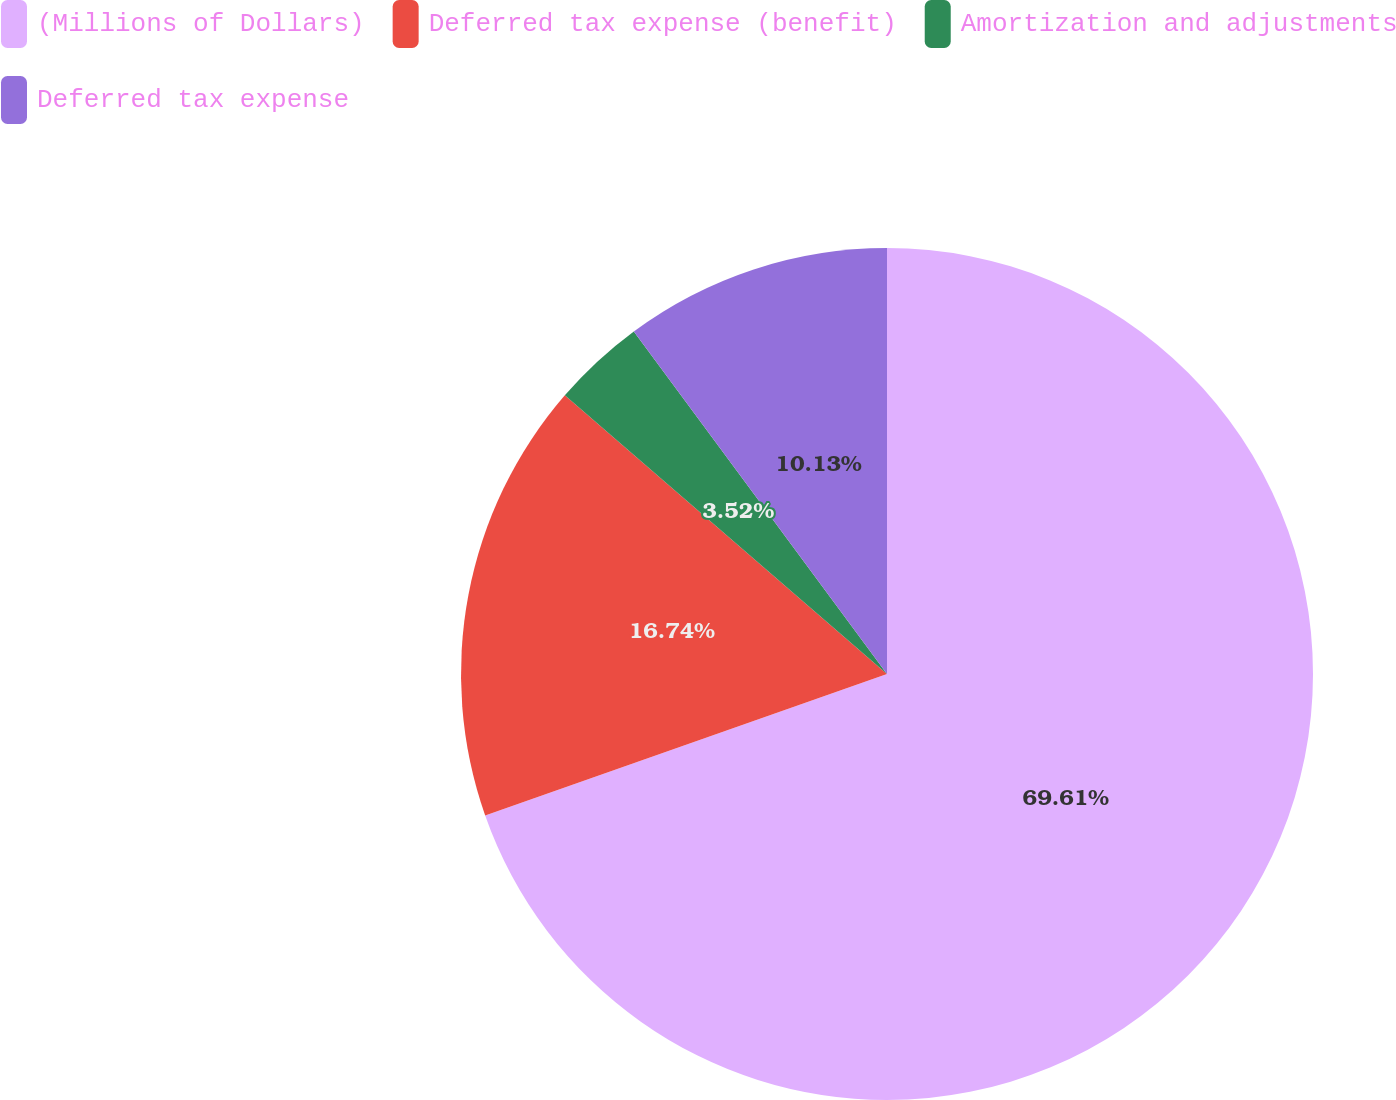Convert chart to OTSL. <chart><loc_0><loc_0><loc_500><loc_500><pie_chart><fcel>(Millions of Dollars)<fcel>Deferred tax expense (benefit)<fcel>Amortization and adjustments<fcel>Deferred tax expense<nl><fcel>69.62%<fcel>16.74%<fcel>3.52%<fcel>10.13%<nl></chart> 